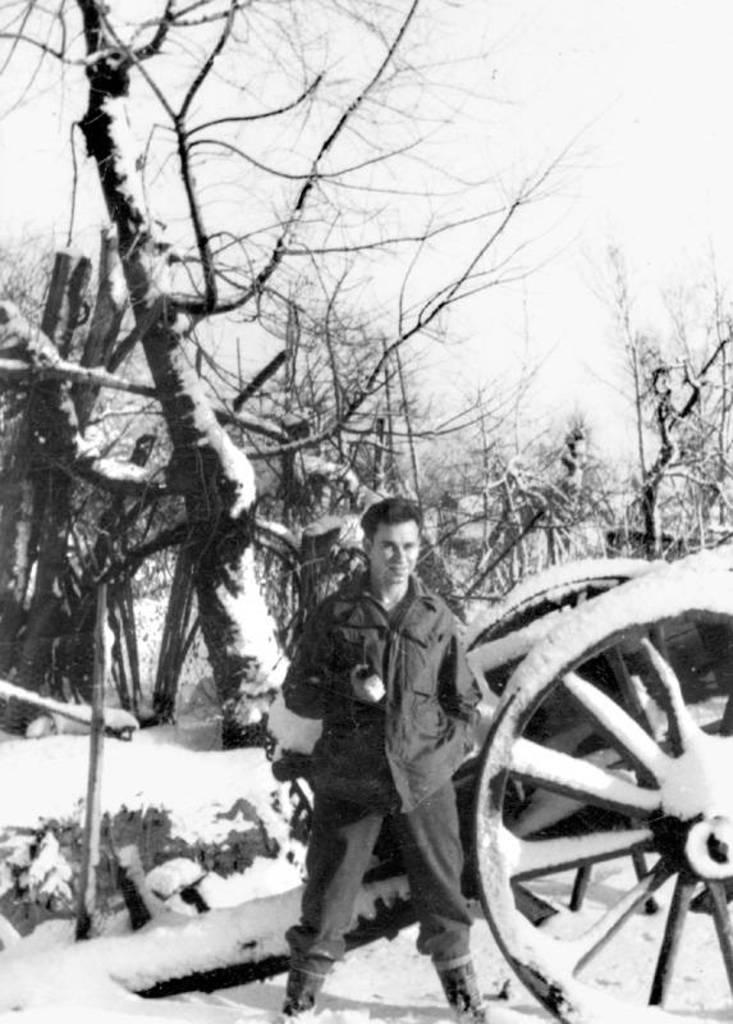How would you summarize this image in a sentence or two? This is a black and white image. In this image we can see a man standing. We can also see the trees and also the cart vehicle. We can see the sky and also the snow. 